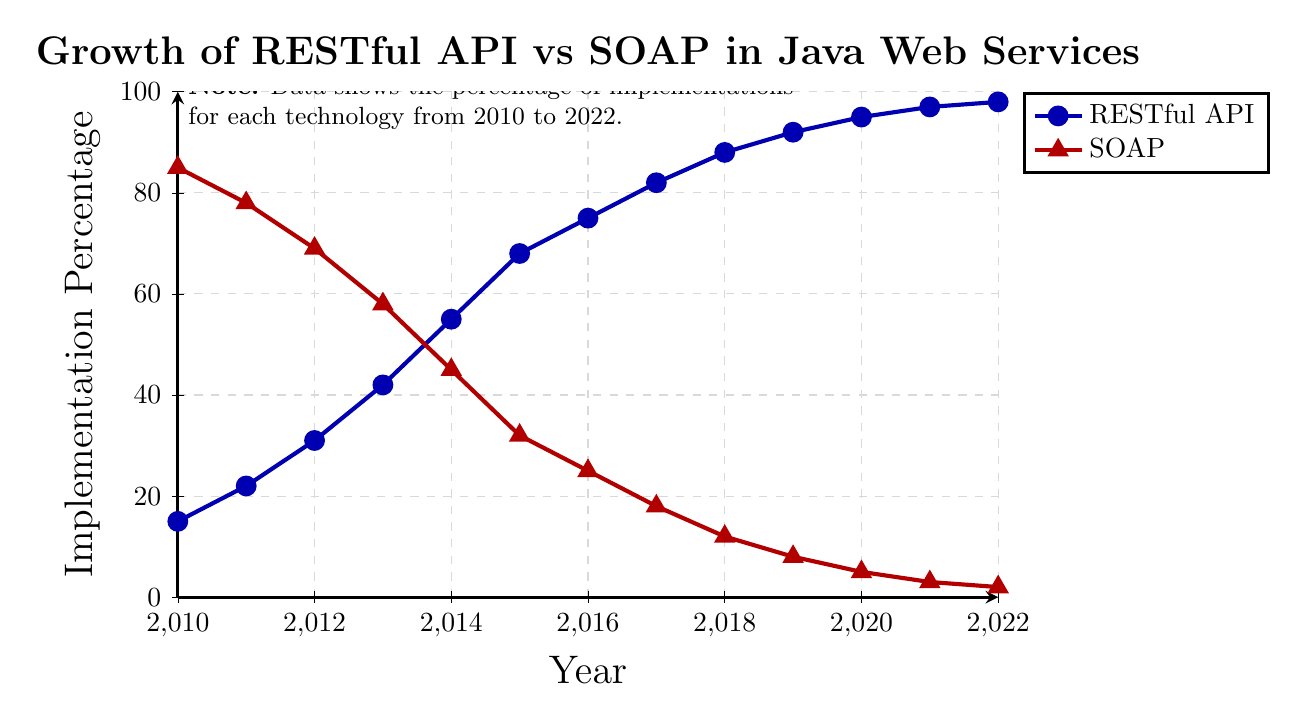what trend can be observed regarding the percentage of SOAP implementations over the years? By examining the red line, it can be observed that the percentage of SOAP implementations decreases consistently from 2010 (85%) to 2022 (2%)
Answer: it decreases consistently In which year do RESTful API and SOAP implementations reach 50% each? From the figure, in 2014, RESTful API implementations reach 55% while SOAP implementations fall to 45%, meaning they cross around 50% at this point
Answer: 2014 What is the difference in implementation percentages between RESTful API and SOAP in 2019? In 2019, the RESTful API implementation is at 92% and SOAP implementation is at 8%. The difference is 92% - 8% = 84%
Answer: 84% Are there any years where the increase in RESTful API implementations is constant? Comparing the RESTful API line across the years, the increase in percentage each year is not constant but generally shows a steady increase
Answer: no Which year has the highest growth in RESTful API implementations? By examining the blue line, the highest growth happens in 2014 where RESTful API implementations jumped from 42% in 2013 to 55% in 2014
Answer: 2014 Between 2015 and 2016, how much did the percentage of SOAP implementations decrease? In 2015, SOAP implementations were at 32% and in 2016 they were at 25%. The decrease is 32% - 25% = 7%
Answer: 7% What can you infer about the adoption trend of RESTful APIs compared to SOAP from 2010 to 2022? The blue line rises sharply while the red line falls dramatically over the same period, indicating a strong adoption trend toward RESTful APIs and away from SOAP
Answer: strong increase in RESTful APIs Which technology had a larger number of years with a higher percentage of implementations? By comparing the lines, SOAP had a higher percentage from 2010 to 2013, while RESTful APIs had a higher percentage from 2014 to 2022. SOAP: 4 years, RESTful APIs: 9 years
Answer: RESTful APIs How much did the percentage of RESTful API implementations increase from 2010 to 2022? The percentage of RESTful API implementations increased from 15% in 2010 to 98% in 2022. So, the increase is 98% - 15% = 83%
Answer: 83% What visual indicator is used to represent SOAP implementations? The SOAP implementations are represented by a red line with triangle markers
Answer: red line with triangles 